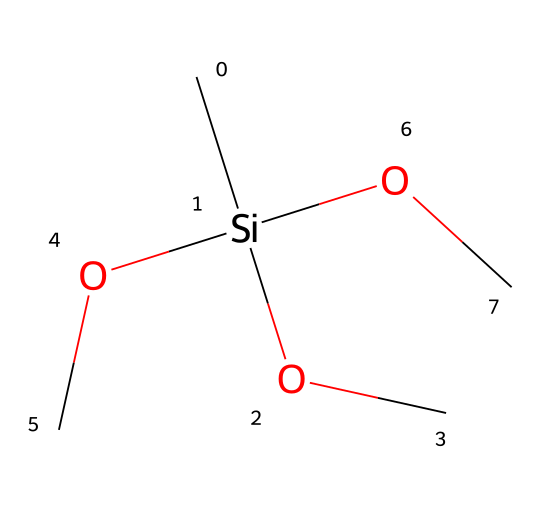What is the central atom in this chemical structure? The central atom in the given SMILES representation is Silicon, indicated by the notation "[Si]". Silicon is commonly used in silanes.
Answer: Silicon How many oxygen atoms are present in this chemical? In the chemical structure, there are three "O" notations representing Oxygen atoms connected to the Silicon atom.
Answer: three What is the total number of carbon atoms in this molecule? The chemical includes three "C" notations before the "[Si]" and represents three carbon atoms.
Answer: three What type of chemical is represented by this structure? This structure represents a silane, as evidenced by the presence of Silicon and its bonding with carbon and oxygen atoms.
Answer: silane How many total bonds are formed by the silicon atom in this structure? The Silicon atom is connected to three Carbon atoms (each through a single bond) and one Oxygen atom (through a single bond), resulting in a total of four bonds.
Answer: four What functionality is indicated by the presence of multiple -O- groups in this molecule? The multiple -O- groups indicate that this silane may have water-repellent properties, as these functional groups contribute to hydrophobic characteristics.
Answer: water-repellent What effect does the structure likely have on water permeability? The presence of silane groups, particularly with oxygen and carbon, typically promotes water repellency, which reduces water permeability in surfaces treated with this compound.
Answer: reduces 